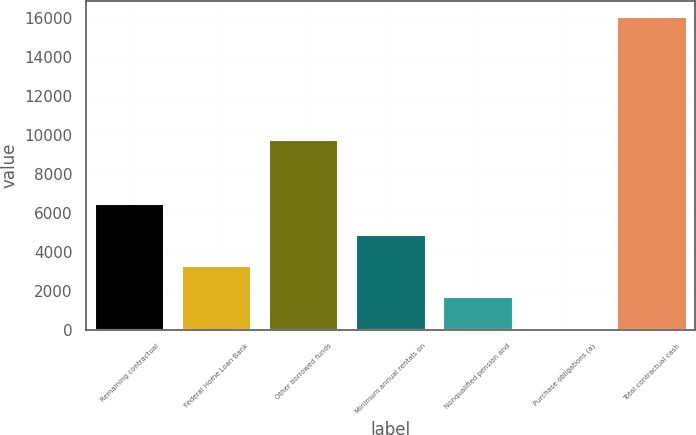Convert chart. <chart><loc_0><loc_0><loc_500><loc_500><bar_chart><fcel>Remaining contractual<fcel>Federal Home Loan Bank<fcel>Other borrowed funds<fcel>Minimum annual rentals on<fcel>Nonqualified pension and<fcel>Purchase obligations (a)<fcel>Total contractual cash<nl><fcel>6457.6<fcel>3258.8<fcel>9722<fcel>4858.2<fcel>1659.4<fcel>60<fcel>16054<nl></chart> 